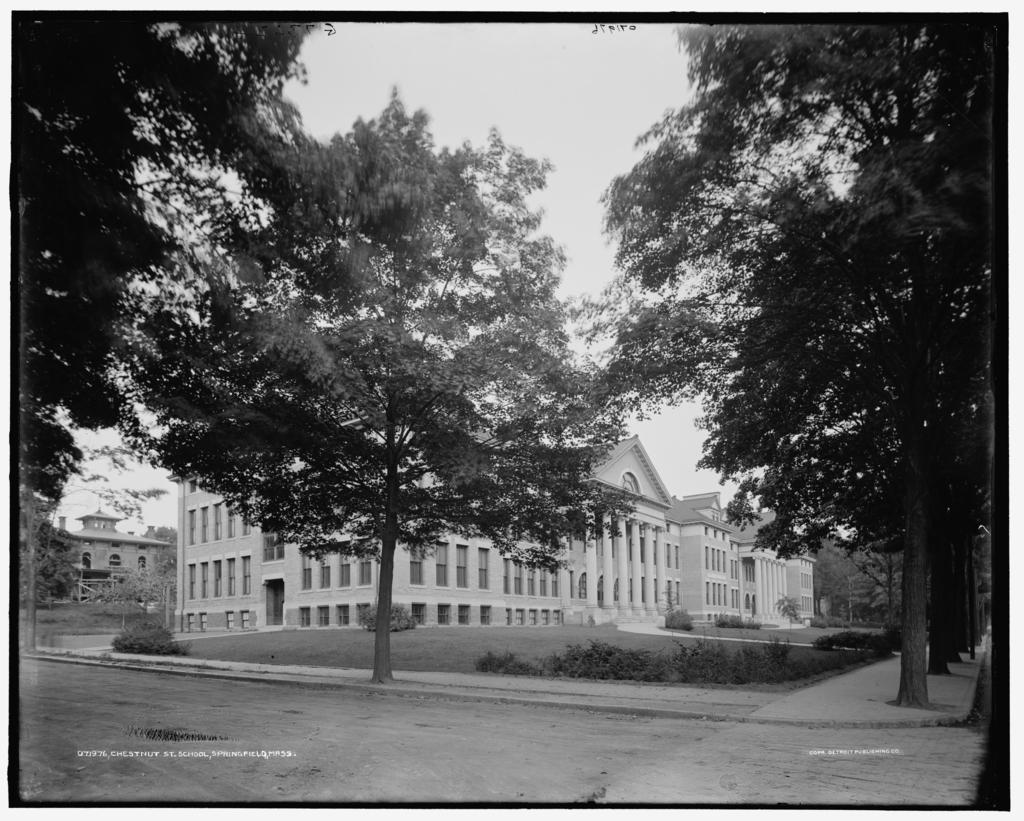What type of image is present in the picture? The image contains a black and white photograph. What is the main subject of the photograph? The photograph depicts buildings. What other elements can be seen in the photograph? Trees and grass are visible in the photograph. What type of spoon is being used by the spy in the photograph? There is no spoon or spy present in the photograph; it only depicts buildings, trees, and grass. 